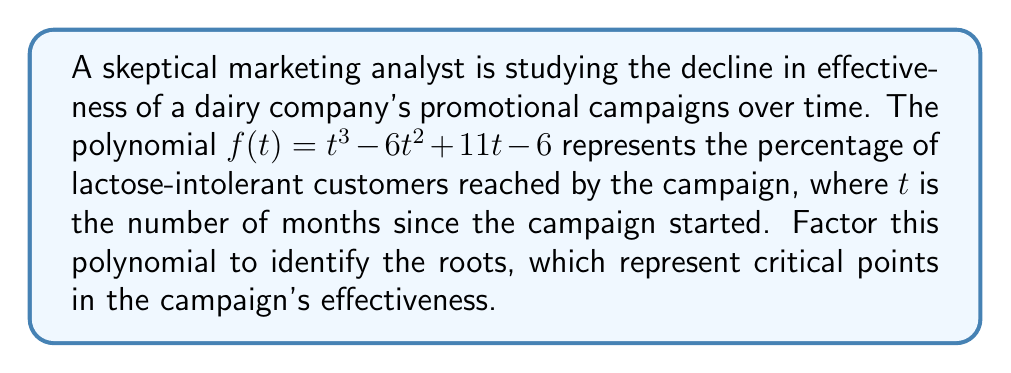Can you answer this question? Let's factor this polynomial step-by-step:

1) First, we'll check if there are any rational roots using the rational root theorem. The possible rational roots are the factors of the constant term: ±1, ±2, ±3, ±6.

2) Testing these values, we find that $f(1) = 0$. So $(t-1)$ is a factor.

3) We can use polynomial long division to divide $f(t)$ by $(t-1)$:

   $$\frac{t^3 - 6t^2 + 11t - 6}{t-1} = t^2 - 5t + 6$$

4) So now we have: $f(t) = (t-1)(t^2 - 5t + 6)$

5) The quadratic factor $t^2 - 5t + 6$ can be factored further:
   
   $t^2 - 5t + 6 = (t-2)(t-3)$

6) Therefore, the fully factored polynomial is:

   $f(t) = (t-1)(t-2)(t-3)$

This factorization reveals that the roots of the polynomial are at $t=1$, $t=2$, and $t=3$, representing critical points at 1, 2, and 3 months after the campaign started.
Answer: $f(t) = (t-1)(t-2)(t-3)$ 